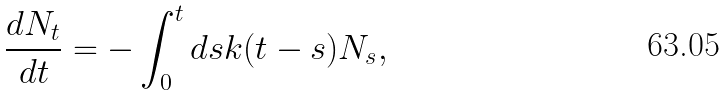Convert formula to latex. <formula><loc_0><loc_0><loc_500><loc_500>\frac { d N _ { t } } { d t } = - \int _ { 0 } ^ { t } d s k ( t - s ) N _ { s } ,</formula> 